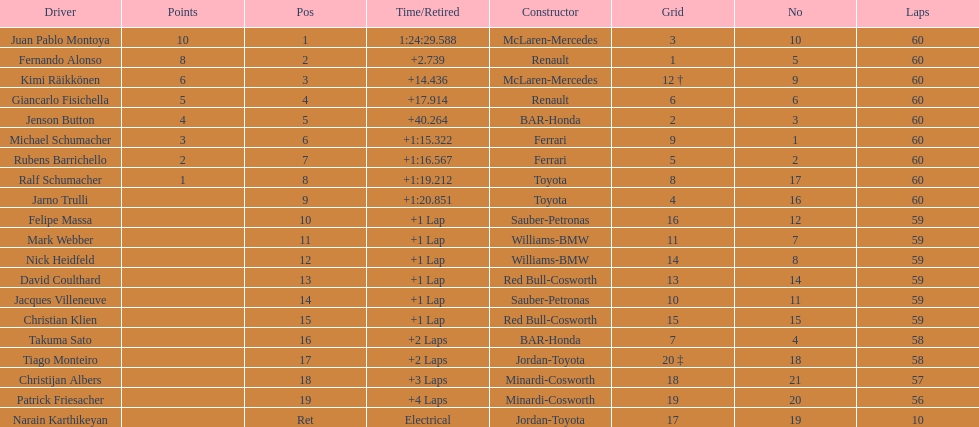Which driver has the least amount of points? Ralf Schumacher. 